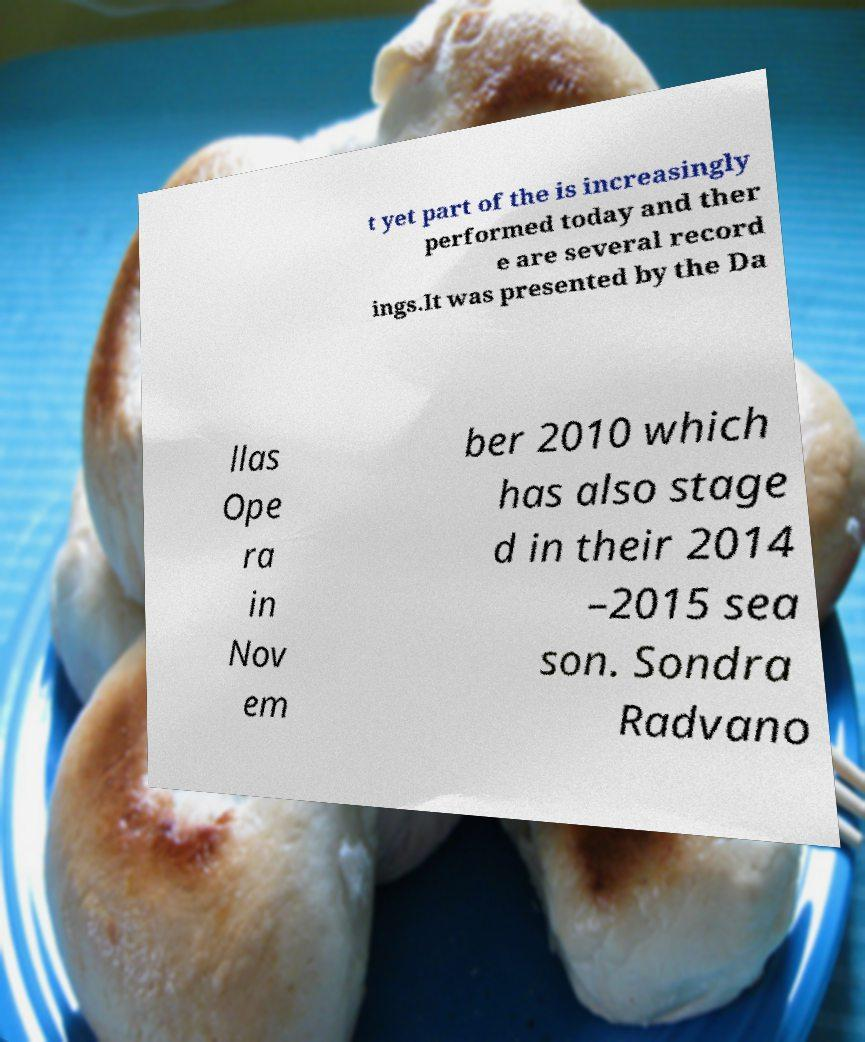For documentation purposes, I need the text within this image transcribed. Could you provide that? t yet part of the is increasingly performed today and ther e are several record ings.It was presented by the Da llas Ope ra in Nov em ber 2010 which has also stage d in their 2014 –2015 sea son. Sondra Radvano 